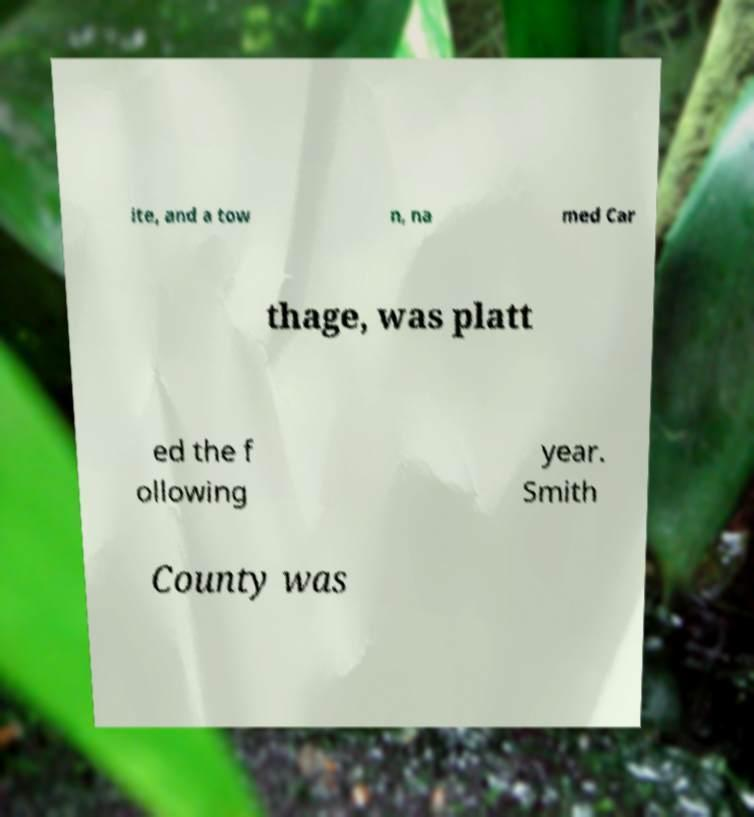Could you assist in decoding the text presented in this image and type it out clearly? ite, and a tow n, na med Car thage, was platt ed the f ollowing year. Smith County was 